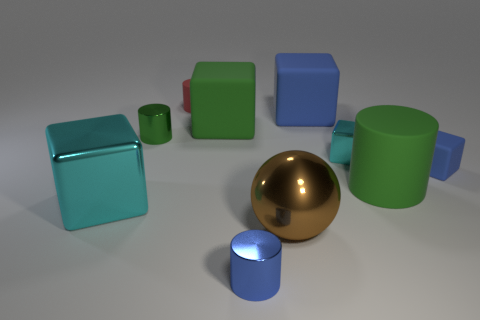Is the big cube behind the large green cube made of the same material as the cyan object that is to the right of the blue shiny cylinder?
Provide a short and direct response. No. The cyan metal object that is in front of the small blue thing behind the large green rubber thing right of the tiny cyan object is what shape?
Offer a very short reply. Cube. The tiny red rubber object has what shape?
Offer a terse response. Cylinder. What shape is the blue shiny thing that is the same size as the red object?
Provide a short and direct response. Cylinder. How many other things are the same color as the small metal block?
Offer a terse response. 1. Does the big object that is on the left side of the tiny red matte cylinder have the same shape as the small rubber thing that is on the right side of the small cyan object?
Offer a terse response. Yes. How many things are cyan things to the left of the big blue rubber block or tiny metal things that are to the left of the small red matte cylinder?
Your answer should be very brief. 2. What number of other objects are there of the same material as the brown ball?
Ensure brevity in your answer.  4. Is the cyan thing to the left of the large brown sphere made of the same material as the large brown object?
Provide a short and direct response. Yes. Are there more cubes that are to the left of the small blue rubber object than large cyan cubes that are behind the small blue metallic cylinder?
Provide a succinct answer. Yes. 